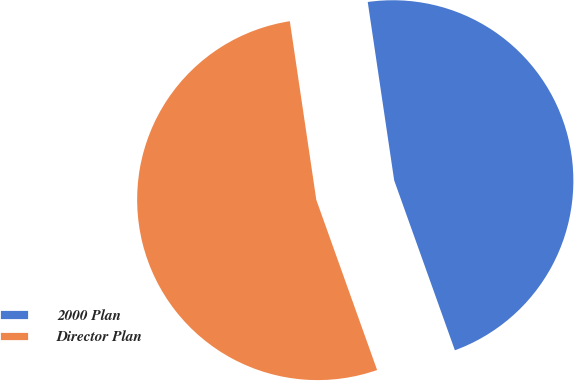Convert chart to OTSL. <chart><loc_0><loc_0><loc_500><loc_500><pie_chart><fcel>2000 Plan<fcel>Director Plan<nl><fcel>46.88%<fcel>53.12%<nl></chart> 